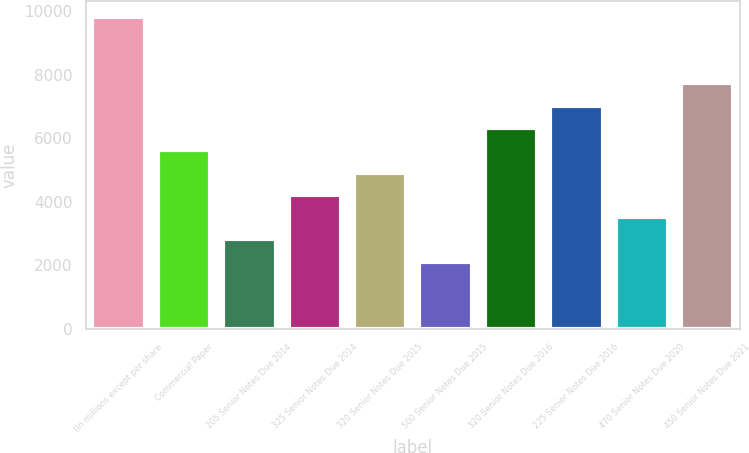Convert chart to OTSL. <chart><loc_0><loc_0><loc_500><loc_500><bar_chart><fcel>(In millions except per share<fcel>Commercial Paper<fcel>205 Senior Notes Due 2014<fcel>325 Senior Notes Due 2014<fcel>320 Senior Notes Due 2015<fcel>500 Senior Notes Due 2015<fcel>320 Senior Notes Due 2016<fcel>225 Senior Notes Due 2016<fcel>470 Senior Notes Due 2020<fcel>450 Senior Notes Due 2021<nl><fcel>9834.4<fcel>5624.8<fcel>2818.4<fcel>4221.6<fcel>4923.2<fcel>2116.8<fcel>6326.4<fcel>7028<fcel>3520<fcel>7729.6<nl></chart> 